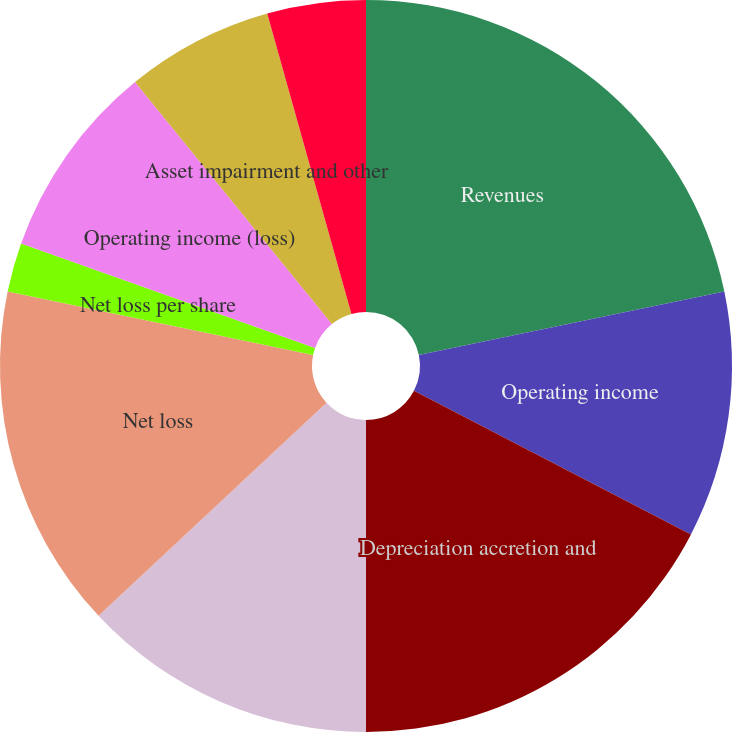Convert chart. <chart><loc_0><loc_0><loc_500><loc_500><pie_chart><fcel>Revenues<fcel>Operating income<fcel>Depreciation accretion and<fcel>Loss from continuing<fcel>Net loss<fcel>Loss per share from continuing<fcel>Net loss per share<fcel>Operating income (loss)<fcel>Asset impairment and other<fcel>Gain (loss) from discontinued<nl><fcel>21.74%<fcel>10.87%<fcel>17.39%<fcel>13.04%<fcel>15.22%<fcel>0.0%<fcel>2.17%<fcel>8.7%<fcel>6.52%<fcel>4.35%<nl></chart> 